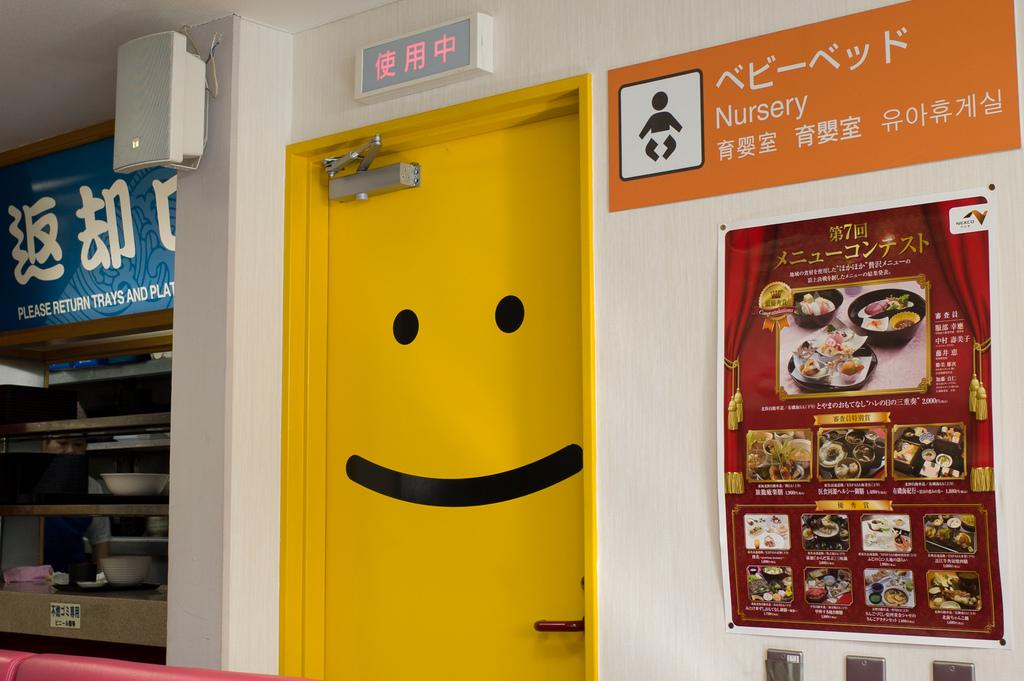Provide a one-sentence caption for the provided image. a room with a yellow door that has a sign that says 'nursery' on it. 